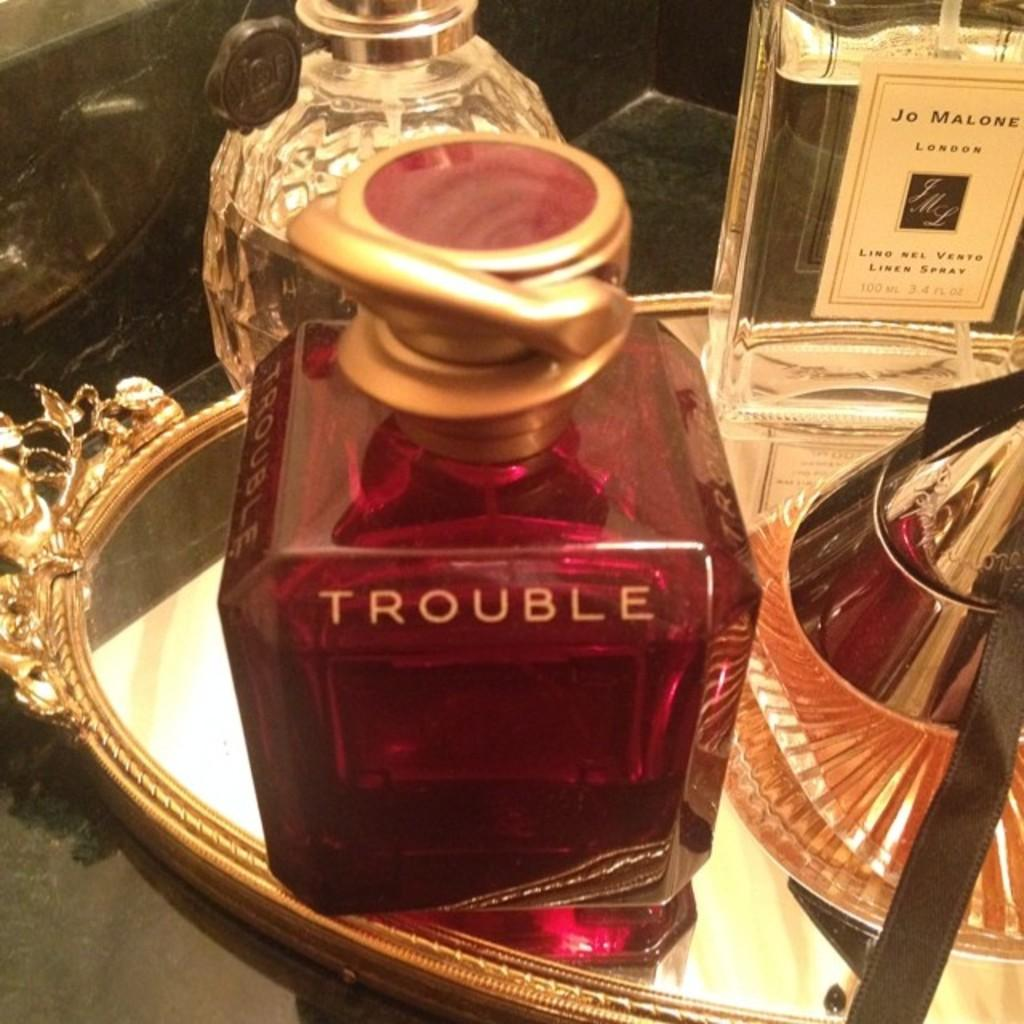What is present in the image that is typically used for serving or storing beverages? There are wine bottles in the image. How are the wine bottles arranged or organized in the image? The wine bottles are in a tray. Where is the tray with wine bottles located in the image? The tray with wine bottles is on a table. Can you tell me how many wrens are perched on the wine bottles in the image? There are no wrens present in the image; it only features wine bottles in a tray on a table. What type of horse can be seen drinking from the wine bottles in the image? There are no horses present in the image, and the wine bottles are not being consumed by any animals. 